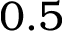Convert formula to latex. <formula><loc_0><loc_0><loc_500><loc_500>0 . 5</formula> 